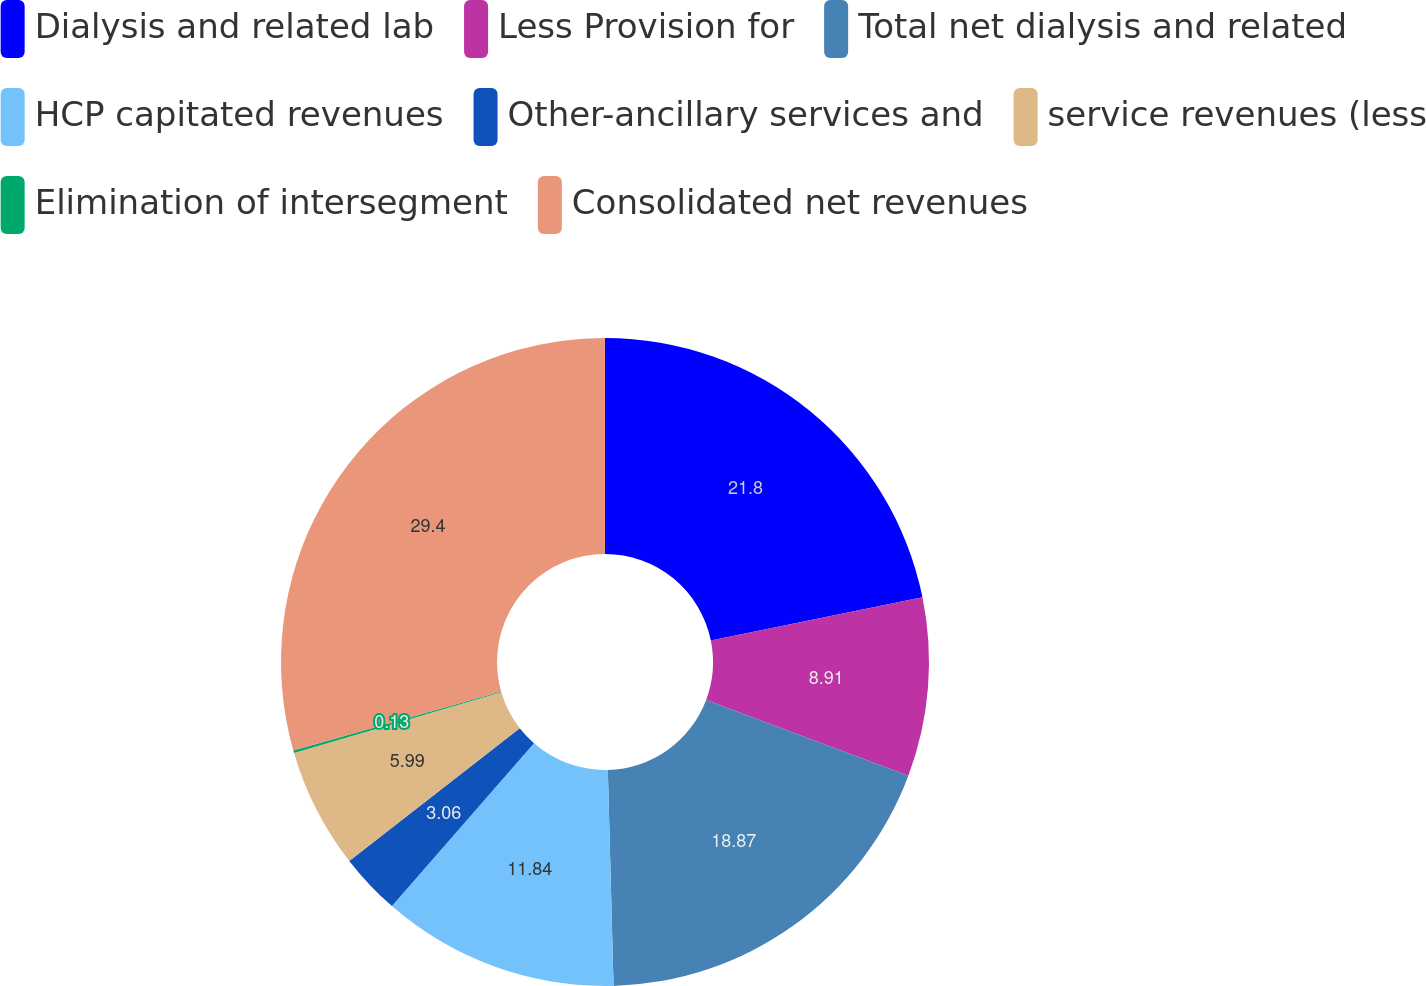<chart> <loc_0><loc_0><loc_500><loc_500><pie_chart><fcel>Dialysis and related lab<fcel>Less Provision for<fcel>Total net dialysis and related<fcel>HCP capitated revenues<fcel>Other-ancillary services and<fcel>service revenues (less<fcel>Elimination of intersegment<fcel>Consolidated net revenues<nl><fcel>21.8%<fcel>8.91%<fcel>18.87%<fcel>11.84%<fcel>3.06%<fcel>5.99%<fcel>0.13%<fcel>29.4%<nl></chart> 